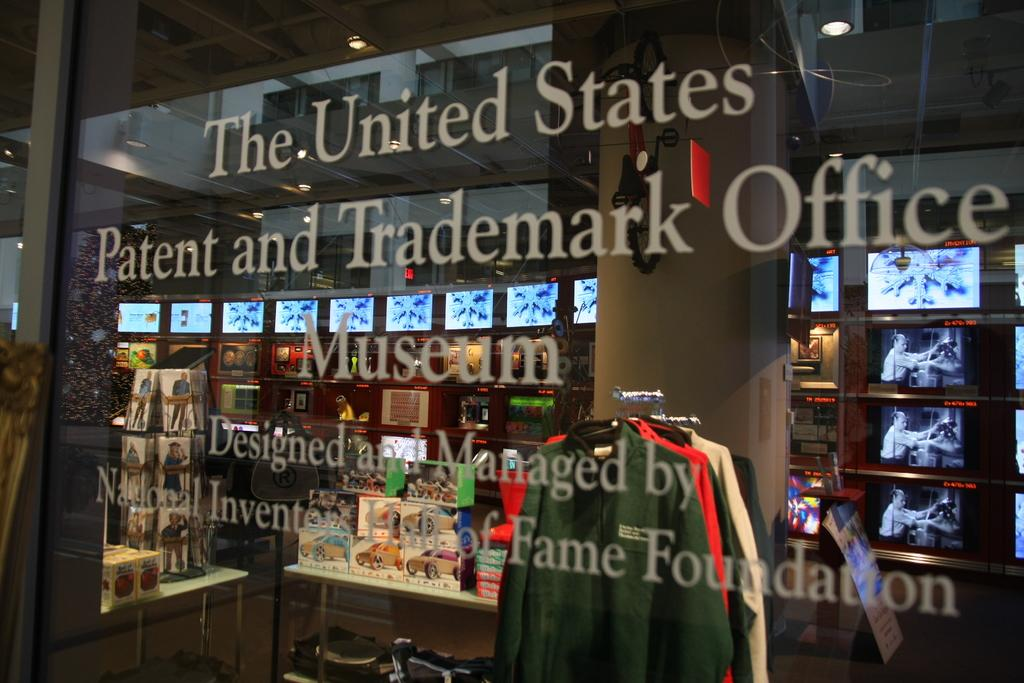<image>
Summarize the visual content of the image. the US Trademark office has many screens inside it 